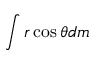<formula> <loc_0><loc_0><loc_500><loc_500>\int r \cos \theta d m</formula> 